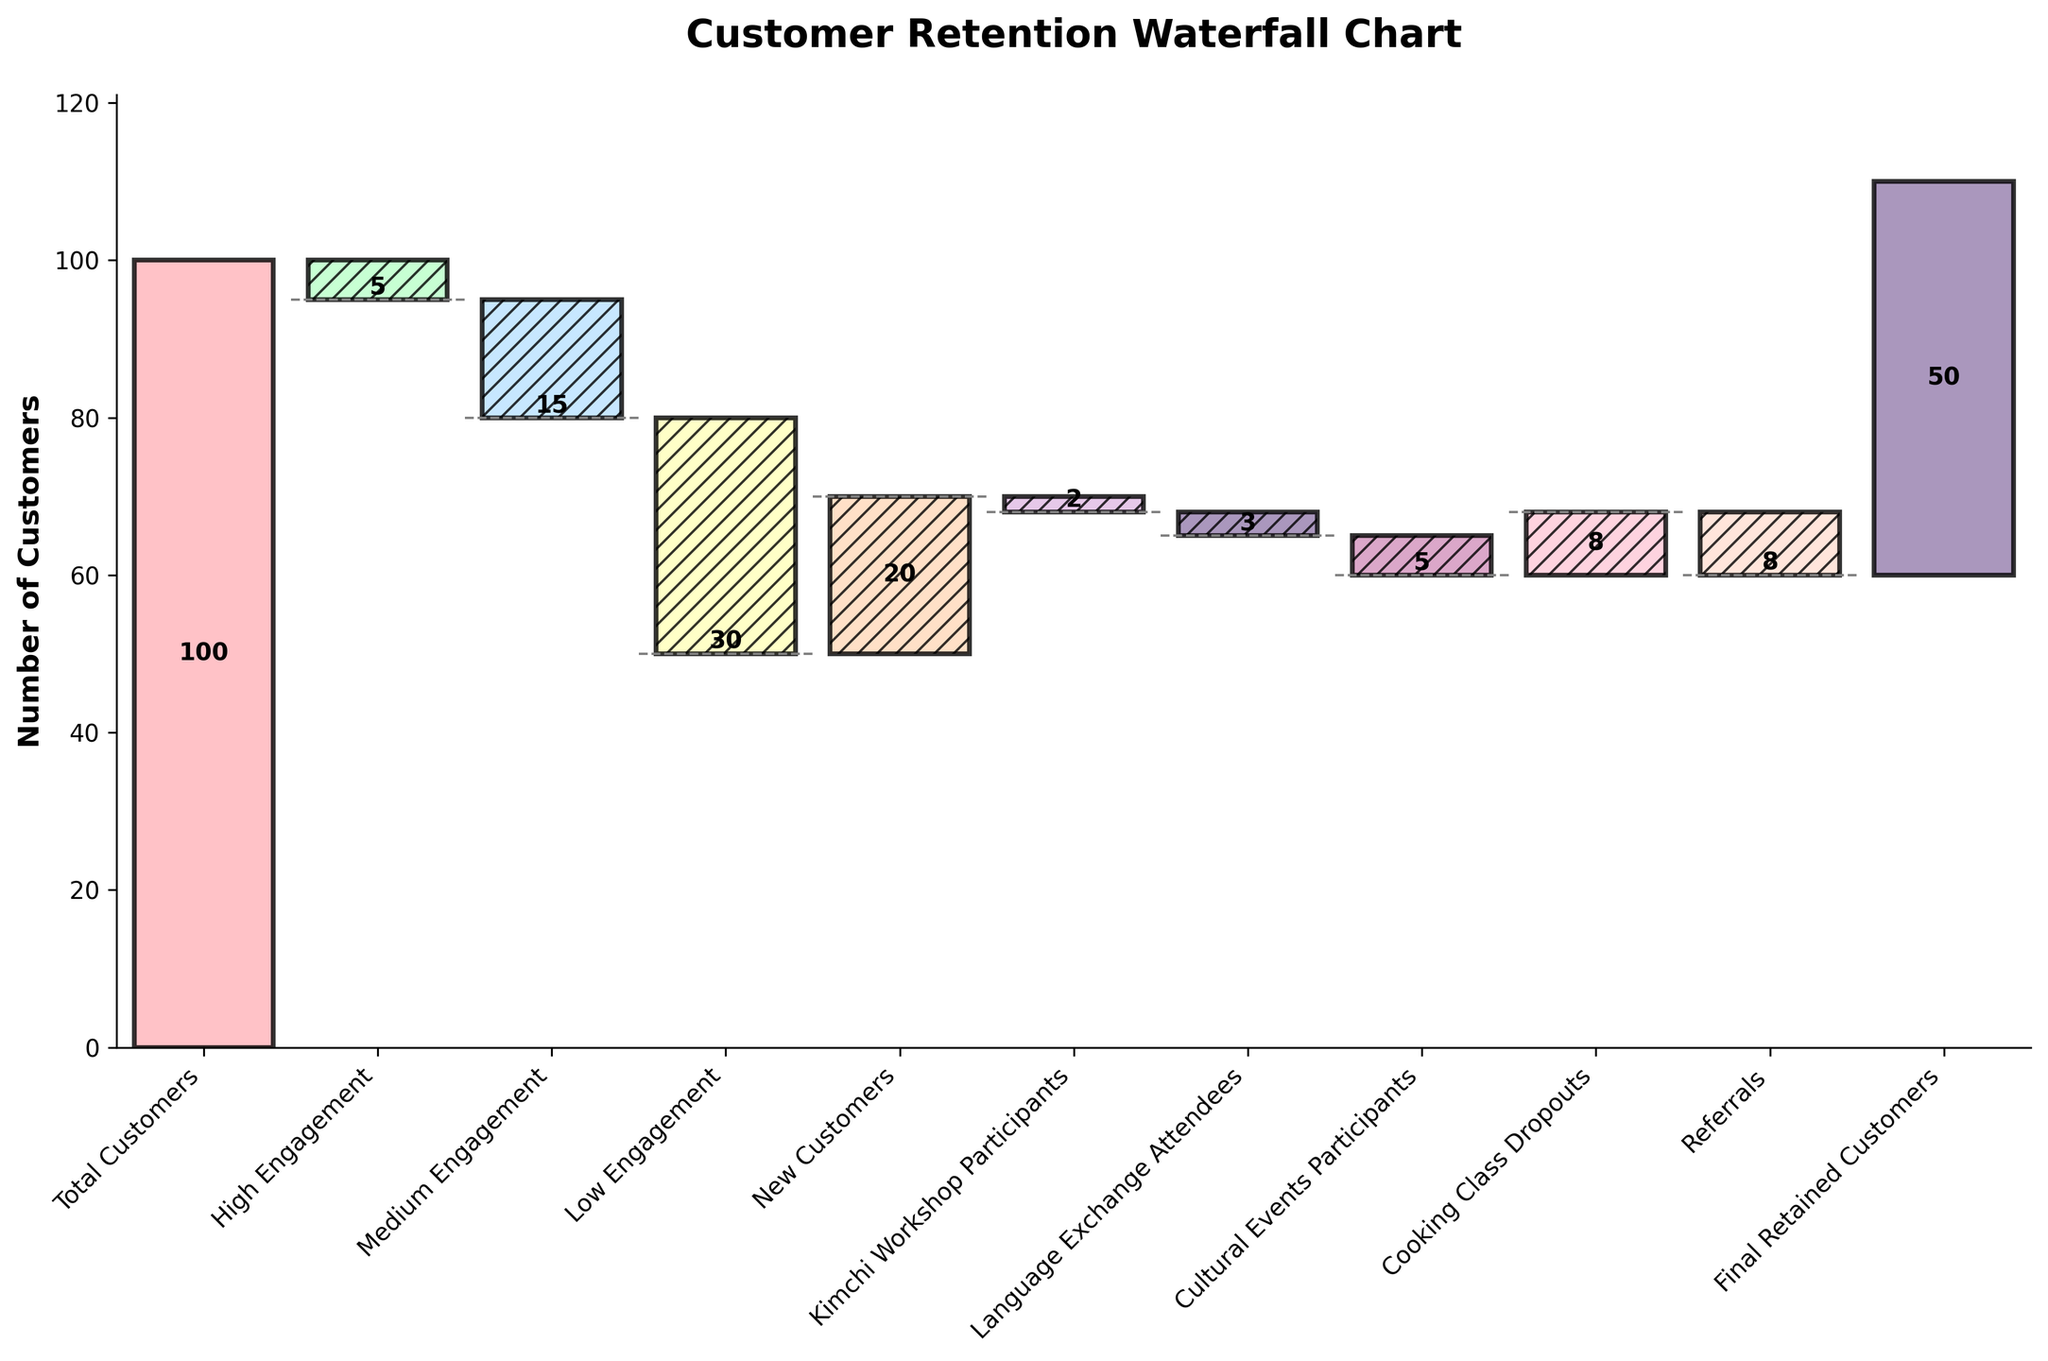What's the title of the figure? The title of the figure is displayed at the top in bold, providing a summary of what the figure represents.
Answer: Customer Retention Waterfall Chart How many total categories are there in the waterfall chart? Count the number of bars or distinct labels on the x-axis that represent different categories.
Answer: 11 Which category had the highest negative impact on customer retention? Look for the category with the tallest bar in the negative direction (downwards).
Answer: Low Engagement How many new customers joined, according to the chart? Identify the bar labeled "New Customers" and note the value associated with it.
Answer: 20 What is the final retained customer count? Look for the last bar on the right and check the label for its value.
Answer: 50 What was the overall impact of customer referrals on customer retention? Identify the bar labeled "Referrals" and note its value, considering it is negative.
Answer: -8 Compare the impact on customer retention between "Cooking Class Dropouts" and "Kimchi Workshop Participants." Which had a greater positive influence? Evaluate the values for both categories and determine which one is more positive.
Answer: Cooking Class Dropouts had a greater positive influence What is the cumulative retention figure after "Medium Engagement"? Calculate the cumulative sum up to and including the value associated with "Medium Engagement."
Answer: 80 How much did "Language Exchange Attendees" and "Cultural Events Participants" combined impact the retention negatively? Add the negative values associated with "Language Exchange Attendees" and "Cultural Events Participants."
Answer: -8 Explain the visual transition from "Total Customers" to "Final Retained Customers." Identify the sequence of changes and visualize each step's addition or subtraction to explain the transition from the initial to final value.
Answer: Starts at 100, decreases by 5, then decreases by 15, decreases further by 30, increases by 20, decreases by 2, decreases by 3, decreases by 5, increases by 8, decreases by 8, reaching 50 